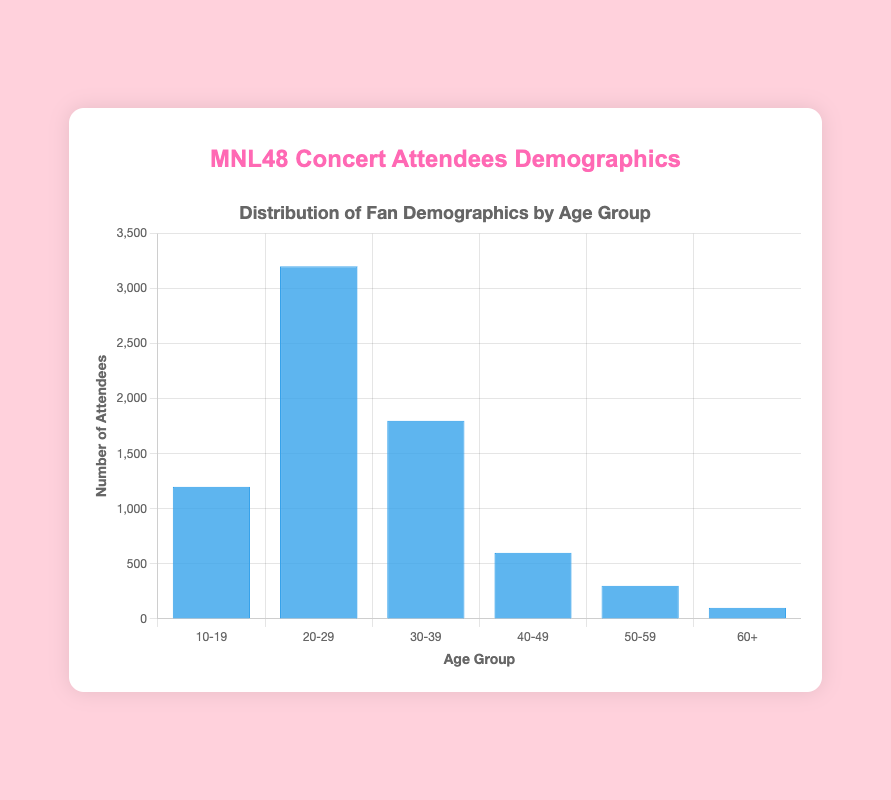What is the total number of concert attendees across all age groups? To find the total number, add the number of attendees from all age groups: 1200 (10–19) + 3200 (20–29) + 1800 (30–39) + 600 (40–49) + 300 (50–59) + 100 (60+). The sum is 7200.
Answer: 7200 Which age group has the highest number of attendees? By comparing the heights of the bars, the 20-29 age group has the tallest bar, indicating the highest number of attendees at 3200.
Answer: 20-29 Between which two consecutive age groups is the largest decrease in the number of attendees? By comparing the differences between consecutive age groups: (3200 - 1800 = 1400), (1800 - 600 = 1200), (600 - 300 = 300), (300 - 100 = 200), the largest decrease is between the 20-29 and 30-39 age groups.
Answer: 20-29 and 30-39 What is the average number of attendees per age group? Sum all attendees (7200) and divide by the number of age groups (6). The calculation is 7200 / 6 = 1200.
Answer: 1200 How many more attendees are there in the 20-29 age group compared to the 10-19 age group? Subtract the number of attendees in the 10-19 age group from the 20-29 age group: 3200 - 1200 = 2000.
Answer: 2000 Is the number of attendees in the 30-39 age group greater than the combined number of attendees in the 50-59 and 60+ age groups? Add the attendees in the 50-59 and 60+ age groups: 300 + 100 = 400. Compare this to the 30-39 age group: 1800 > 400.
Answer: Yes Which is taller, the combined height of the bars for the 40-49 and 50-59 age groups or the bar for the 30-39 age group? Add the attendees for the 40-49 and 50-59 age groups: 600 + 300 = 900. Compare this to the 30-39 age group: 1800 > 900.
Answer: The bar for the 30-39 age group What is the percentage of attendees in the 40-49 age group out of the total attendees? Divide the number of attendees in the 40-49 age group by the total number of attendees and multiply by 100: (600 / 7200) * 100 ≈ 8.33%.
Answer: 8.33% How does the number of attendees in the 50-59 age group compare to the number in the 10-19 age group? By comparing the heights of the bars, the 10-19 age group (1200 attendees) is significantly larger than the 50-59 age group (300 attendees).
Answer: The 10-19 age group is larger If the number of attendees in the 20-29 age group doubled, what would be the new total number of attendees? Double the attendees in the 20-29 age group: 3200 * 2 = 6400. Sum all attendees: 1200 + 6400 + 1800 + 600 + 300 + 100 = 10300.
Answer: 10300 